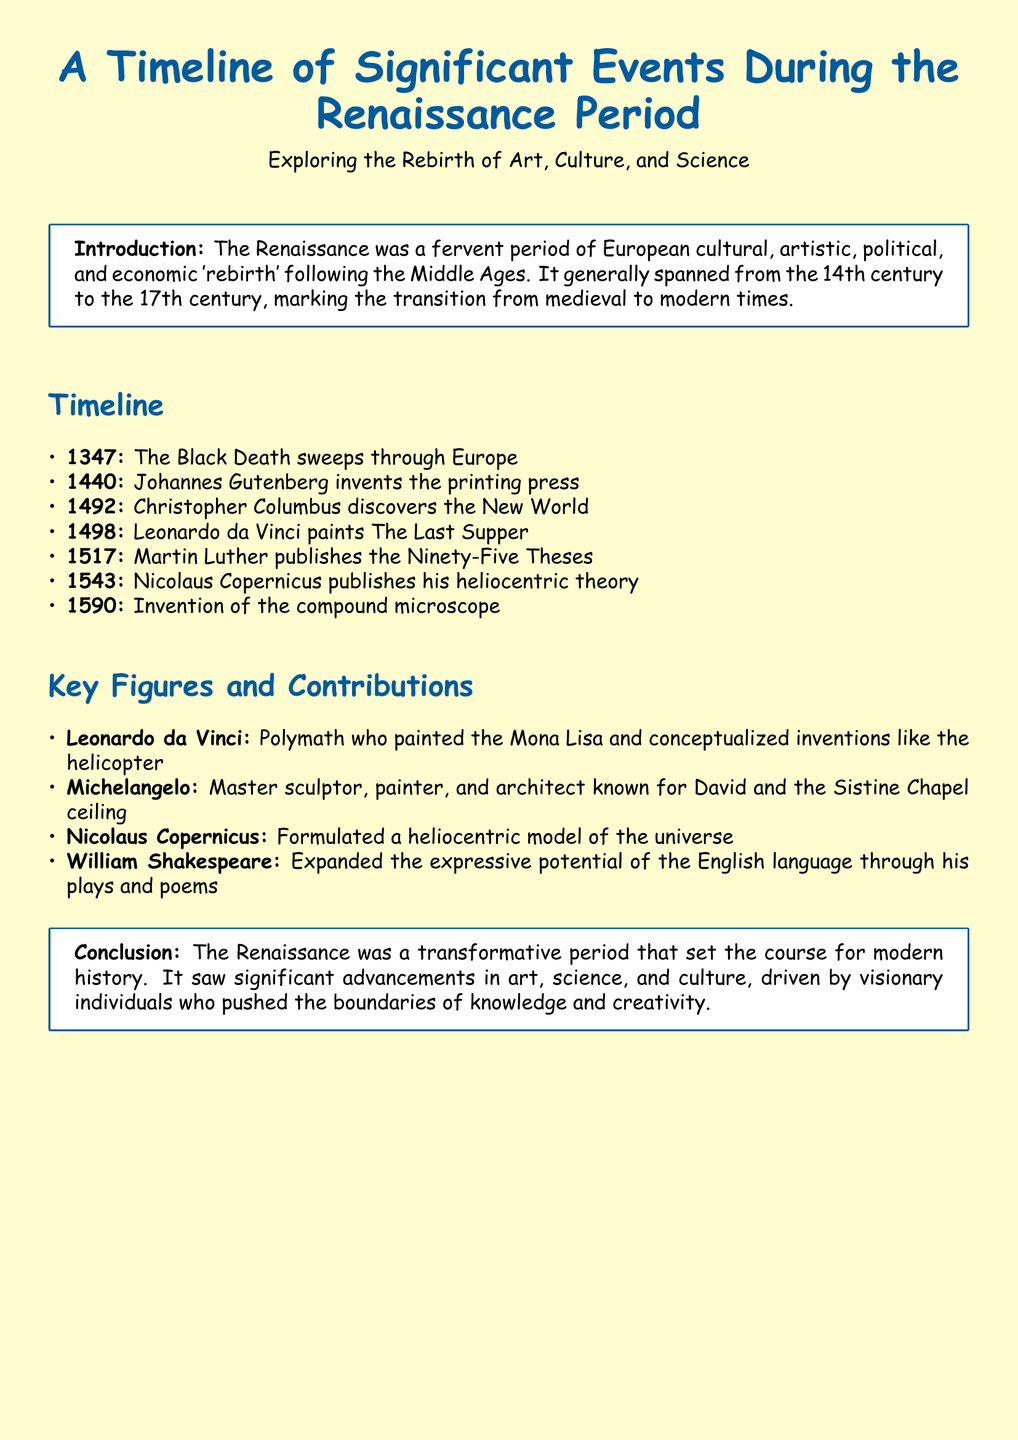What year did Johannes Gutenberg invent the printing press? The document states that Johannes Gutenberg invented the printing press in the year 1440.
Answer: 1440 Who painted The Last Supper? According to the document, Leonardo da Vinci is credited with painting The Last Supper.
Answer: Leonardo da Vinci What significant event occurred in 1492? The document mentions the discovery of the New World by Christopher Columbus in 1492.
Answer: Christopher Columbus discovers the New World Which figure is known for the Sistine Chapel ceiling? The document identifies Michelangelo as the master known for the Sistine Chapel ceiling.
Answer: Michelangelo What theory did Nicolaus Copernicus publish in 1543? Nicolaus Copernicus published his heliocentric theory in 1543, as stated in the document.
Answer: Heliocentric theory How did the Renaissance influence modern history? The document concludes that the Renaissance was transformative, impacting advancements in art, science, and culture.
Answer: Transformative period Which invention is associated with the year 1590? The document notes that the compound microscope was invented in the year 1590.
Answer: Compound microscope What was Martin Luther's significant publication in 1517? Martin Luther published the Ninety-Five Theses in 1517, as mentioned in the document.
Answer: Ninety-Five Theses 